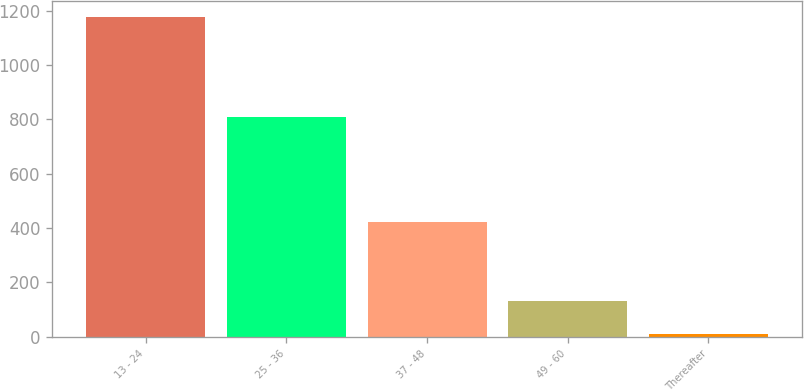Convert chart to OTSL. <chart><loc_0><loc_0><loc_500><loc_500><bar_chart><fcel>13 - 24<fcel>25 - 36<fcel>37 - 48<fcel>49 - 60<fcel>Thereafter<nl><fcel>1177<fcel>808<fcel>422<fcel>130<fcel>9<nl></chart> 